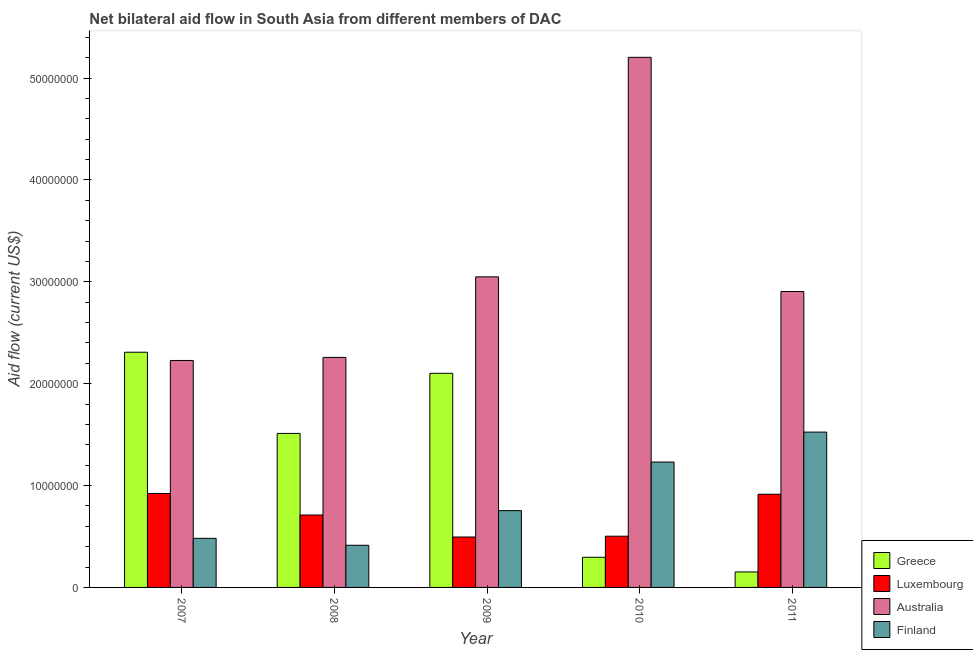How many bars are there on the 4th tick from the left?
Provide a short and direct response. 4. How many bars are there on the 1st tick from the right?
Your answer should be very brief. 4. What is the label of the 5th group of bars from the left?
Your answer should be compact. 2011. In how many cases, is the number of bars for a given year not equal to the number of legend labels?
Your response must be concise. 0. What is the amount of aid given by australia in 2008?
Provide a short and direct response. 2.26e+07. Across all years, what is the maximum amount of aid given by greece?
Offer a terse response. 2.31e+07. Across all years, what is the minimum amount of aid given by finland?
Ensure brevity in your answer.  4.14e+06. In which year was the amount of aid given by greece minimum?
Your answer should be very brief. 2011. What is the total amount of aid given by finland in the graph?
Offer a very short reply. 4.41e+07. What is the difference between the amount of aid given by luxembourg in 2007 and that in 2011?
Ensure brevity in your answer.  7.00e+04. What is the difference between the amount of aid given by australia in 2008 and the amount of aid given by luxembourg in 2011?
Your answer should be compact. -6.47e+06. What is the average amount of aid given by finland per year?
Make the answer very short. 8.81e+06. In the year 2011, what is the difference between the amount of aid given by luxembourg and amount of aid given by finland?
Provide a short and direct response. 0. In how many years, is the amount of aid given by finland greater than 18000000 US$?
Give a very brief answer. 0. What is the ratio of the amount of aid given by finland in 2007 to that in 2009?
Ensure brevity in your answer.  0.64. What is the difference between the highest and the second highest amount of aid given by australia?
Give a very brief answer. 2.16e+07. What is the difference between the highest and the lowest amount of aid given by finland?
Provide a short and direct response. 1.11e+07. In how many years, is the amount of aid given by greece greater than the average amount of aid given by greece taken over all years?
Give a very brief answer. 3. What does the 2nd bar from the left in 2008 represents?
Your answer should be compact. Luxembourg. How many bars are there?
Provide a short and direct response. 20. Are all the bars in the graph horizontal?
Provide a short and direct response. No. What is the difference between two consecutive major ticks on the Y-axis?
Offer a terse response. 1.00e+07. Are the values on the major ticks of Y-axis written in scientific E-notation?
Offer a very short reply. No. Does the graph contain grids?
Provide a succinct answer. No. Where does the legend appear in the graph?
Provide a short and direct response. Bottom right. How are the legend labels stacked?
Ensure brevity in your answer.  Vertical. What is the title of the graph?
Make the answer very short. Net bilateral aid flow in South Asia from different members of DAC. Does "Taxes on exports" appear as one of the legend labels in the graph?
Offer a terse response. No. What is the Aid flow (current US$) in Greece in 2007?
Ensure brevity in your answer.  2.31e+07. What is the Aid flow (current US$) of Luxembourg in 2007?
Give a very brief answer. 9.22e+06. What is the Aid flow (current US$) of Australia in 2007?
Keep it short and to the point. 2.23e+07. What is the Aid flow (current US$) in Finland in 2007?
Make the answer very short. 4.82e+06. What is the Aid flow (current US$) of Greece in 2008?
Your response must be concise. 1.51e+07. What is the Aid flow (current US$) in Luxembourg in 2008?
Provide a succinct answer. 7.11e+06. What is the Aid flow (current US$) in Australia in 2008?
Offer a terse response. 2.26e+07. What is the Aid flow (current US$) in Finland in 2008?
Ensure brevity in your answer.  4.14e+06. What is the Aid flow (current US$) in Greece in 2009?
Provide a succinct answer. 2.10e+07. What is the Aid flow (current US$) of Luxembourg in 2009?
Provide a succinct answer. 4.95e+06. What is the Aid flow (current US$) of Australia in 2009?
Ensure brevity in your answer.  3.05e+07. What is the Aid flow (current US$) in Finland in 2009?
Your answer should be compact. 7.54e+06. What is the Aid flow (current US$) of Greece in 2010?
Your answer should be compact. 2.96e+06. What is the Aid flow (current US$) in Luxembourg in 2010?
Offer a terse response. 5.03e+06. What is the Aid flow (current US$) in Australia in 2010?
Make the answer very short. 5.20e+07. What is the Aid flow (current US$) in Finland in 2010?
Your response must be concise. 1.23e+07. What is the Aid flow (current US$) of Greece in 2011?
Keep it short and to the point. 1.52e+06. What is the Aid flow (current US$) of Luxembourg in 2011?
Make the answer very short. 9.15e+06. What is the Aid flow (current US$) of Australia in 2011?
Ensure brevity in your answer.  2.90e+07. What is the Aid flow (current US$) of Finland in 2011?
Provide a short and direct response. 1.52e+07. Across all years, what is the maximum Aid flow (current US$) of Greece?
Your response must be concise. 2.31e+07. Across all years, what is the maximum Aid flow (current US$) of Luxembourg?
Offer a terse response. 9.22e+06. Across all years, what is the maximum Aid flow (current US$) in Australia?
Your response must be concise. 5.20e+07. Across all years, what is the maximum Aid flow (current US$) in Finland?
Provide a succinct answer. 1.52e+07. Across all years, what is the minimum Aid flow (current US$) of Greece?
Ensure brevity in your answer.  1.52e+06. Across all years, what is the minimum Aid flow (current US$) of Luxembourg?
Your answer should be very brief. 4.95e+06. Across all years, what is the minimum Aid flow (current US$) of Australia?
Offer a terse response. 2.23e+07. Across all years, what is the minimum Aid flow (current US$) in Finland?
Ensure brevity in your answer.  4.14e+06. What is the total Aid flow (current US$) of Greece in the graph?
Your answer should be compact. 6.37e+07. What is the total Aid flow (current US$) in Luxembourg in the graph?
Offer a very short reply. 3.55e+07. What is the total Aid flow (current US$) in Australia in the graph?
Give a very brief answer. 1.56e+08. What is the total Aid flow (current US$) in Finland in the graph?
Give a very brief answer. 4.41e+07. What is the difference between the Aid flow (current US$) of Greece in 2007 and that in 2008?
Give a very brief answer. 7.97e+06. What is the difference between the Aid flow (current US$) of Luxembourg in 2007 and that in 2008?
Offer a terse response. 2.11e+06. What is the difference between the Aid flow (current US$) in Finland in 2007 and that in 2008?
Provide a succinct answer. 6.80e+05. What is the difference between the Aid flow (current US$) in Greece in 2007 and that in 2009?
Keep it short and to the point. 2.07e+06. What is the difference between the Aid flow (current US$) of Luxembourg in 2007 and that in 2009?
Ensure brevity in your answer.  4.27e+06. What is the difference between the Aid flow (current US$) of Australia in 2007 and that in 2009?
Your answer should be compact. -8.21e+06. What is the difference between the Aid flow (current US$) of Finland in 2007 and that in 2009?
Offer a terse response. -2.72e+06. What is the difference between the Aid flow (current US$) in Greece in 2007 and that in 2010?
Your answer should be compact. 2.01e+07. What is the difference between the Aid flow (current US$) in Luxembourg in 2007 and that in 2010?
Your answer should be compact. 4.19e+06. What is the difference between the Aid flow (current US$) in Australia in 2007 and that in 2010?
Offer a terse response. -2.98e+07. What is the difference between the Aid flow (current US$) of Finland in 2007 and that in 2010?
Your answer should be compact. -7.49e+06. What is the difference between the Aid flow (current US$) of Greece in 2007 and that in 2011?
Offer a very short reply. 2.16e+07. What is the difference between the Aid flow (current US$) of Luxembourg in 2007 and that in 2011?
Offer a terse response. 7.00e+04. What is the difference between the Aid flow (current US$) of Australia in 2007 and that in 2011?
Ensure brevity in your answer.  -6.77e+06. What is the difference between the Aid flow (current US$) of Finland in 2007 and that in 2011?
Give a very brief answer. -1.04e+07. What is the difference between the Aid flow (current US$) of Greece in 2008 and that in 2009?
Keep it short and to the point. -5.90e+06. What is the difference between the Aid flow (current US$) of Luxembourg in 2008 and that in 2009?
Your answer should be compact. 2.16e+06. What is the difference between the Aid flow (current US$) of Australia in 2008 and that in 2009?
Ensure brevity in your answer.  -7.91e+06. What is the difference between the Aid flow (current US$) of Finland in 2008 and that in 2009?
Ensure brevity in your answer.  -3.40e+06. What is the difference between the Aid flow (current US$) in Greece in 2008 and that in 2010?
Your answer should be compact. 1.22e+07. What is the difference between the Aid flow (current US$) in Luxembourg in 2008 and that in 2010?
Make the answer very short. 2.08e+06. What is the difference between the Aid flow (current US$) of Australia in 2008 and that in 2010?
Your response must be concise. -2.95e+07. What is the difference between the Aid flow (current US$) of Finland in 2008 and that in 2010?
Make the answer very short. -8.17e+06. What is the difference between the Aid flow (current US$) in Greece in 2008 and that in 2011?
Provide a short and direct response. 1.36e+07. What is the difference between the Aid flow (current US$) of Luxembourg in 2008 and that in 2011?
Your answer should be very brief. -2.04e+06. What is the difference between the Aid flow (current US$) in Australia in 2008 and that in 2011?
Provide a succinct answer. -6.47e+06. What is the difference between the Aid flow (current US$) of Finland in 2008 and that in 2011?
Provide a short and direct response. -1.11e+07. What is the difference between the Aid flow (current US$) of Greece in 2009 and that in 2010?
Your response must be concise. 1.81e+07. What is the difference between the Aid flow (current US$) in Luxembourg in 2009 and that in 2010?
Your response must be concise. -8.00e+04. What is the difference between the Aid flow (current US$) in Australia in 2009 and that in 2010?
Give a very brief answer. -2.16e+07. What is the difference between the Aid flow (current US$) of Finland in 2009 and that in 2010?
Offer a very short reply. -4.77e+06. What is the difference between the Aid flow (current US$) in Greece in 2009 and that in 2011?
Keep it short and to the point. 1.95e+07. What is the difference between the Aid flow (current US$) of Luxembourg in 2009 and that in 2011?
Make the answer very short. -4.20e+06. What is the difference between the Aid flow (current US$) in Australia in 2009 and that in 2011?
Offer a terse response. 1.44e+06. What is the difference between the Aid flow (current US$) in Finland in 2009 and that in 2011?
Keep it short and to the point. -7.71e+06. What is the difference between the Aid flow (current US$) of Greece in 2010 and that in 2011?
Your response must be concise. 1.44e+06. What is the difference between the Aid flow (current US$) in Luxembourg in 2010 and that in 2011?
Ensure brevity in your answer.  -4.12e+06. What is the difference between the Aid flow (current US$) of Australia in 2010 and that in 2011?
Give a very brief answer. 2.30e+07. What is the difference between the Aid flow (current US$) in Finland in 2010 and that in 2011?
Make the answer very short. -2.94e+06. What is the difference between the Aid flow (current US$) in Greece in 2007 and the Aid flow (current US$) in Luxembourg in 2008?
Ensure brevity in your answer.  1.60e+07. What is the difference between the Aid flow (current US$) in Greece in 2007 and the Aid flow (current US$) in Australia in 2008?
Offer a very short reply. 5.10e+05. What is the difference between the Aid flow (current US$) in Greece in 2007 and the Aid flow (current US$) in Finland in 2008?
Your answer should be very brief. 1.90e+07. What is the difference between the Aid flow (current US$) of Luxembourg in 2007 and the Aid flow (current US$) of Australia in 2008?
Provide a succinct answer. -1.34e+07. What is the difference between the Aid flow (current US$) in Luxembourg in 2007 and the Aid flow (current US$) in Finland in 2008?
Give a very brief answer. 5.08e+06. What is the difference between the Aid flow (current US$) in Australia in 2007 and the Aid flow (current US$) in Finland in 2008?
Your answer should be very brief. 1.81e+07. What is the difference between the Aid flow (current US$) in Greece in 2007 and the Aid flow (current US$) in Luxembourg in 2009?
Your response must be concise. 1.81e+07. What is the difference between the Aid flow (current US$) of Greece in 2007 and the Aid flow (current US$) of Australia in 2009?
Provide a short and direct response. -7.40e+06. What is the difference between the Aid flow (current US$) of Greece in 2007 and the Aid flow (current US$) of Finland in 2009?
Your response must be concise. 1.56e+07. What is the difference between the Aid flow (current US$) of Luxembourg in 2007 and the Aid flow (current US$) of Australia in 2009?
Make the answer very short. -2.13e+07. What is the difference between the Aid flow (current US$) of Luxembourg in 2007 and the Aid flow (current US$) of Finland in 2009?
Provide a succinct answer. 1.68e+06. What is the difference between the Aid flow (current US$) in Australia in 2007 and the Aid flow (current US$) in Finland in 2009?
Ensure brevity in your answer.  1.47e+07. What is the difference between the Aid flow (current US$) of Greece in 2007 and the Aid flow (current US$) of Luxembourg in 2010?
Make the answer very short. 1.81e+07. What is the difference between the Aid flow (current US$) in Greece in 2007 and the Aid flow (current US$) in Australia in 2010?
Provide a succinct answer. -2.90e+07. What is the difference between the Aid flow (current US$) of Greece in 2007 and the Aid flow (current US$) of Finland in 2010?
Offer a terse response. 1.08e+07. What is the difference between the Aid flow (current US$) in Luxembourg in 2007 and the Aid flow (current US$) in Australia in 2010?
Give a very brief answer. -4.28e+07. What is the difference between the Aid flow (current US$) in Luxembourg in 2007 and the Aid flow (current US$) in Finland in 2010?
Provide a succinct answer. -3.09e+06. What is the difference between the Aid flow (current US$) in Australia in 2007 and the Aid flow (current US$) in Finland in 2010?
Ensure brevity in your answer.  9.97e+06. What is the difference between the Aid flow (current US$) of Greece in 2007 and the Aid flow (current US$) of Luxembourg in 2011?
Keep it short and to the point. 1.39e+07. What is the difference between the Aid flow (current US$) of Greece in 2007 and the Aid flow (current US$) of Australia in 2011?
Make the answer very short. -5.96e+06. What is the difference between the Aid flow (current US$) of Greece in 2007 and the Aid flow (current US$) of Finland in 2011?
Provide a succinct answer. 7.84e+06. What is the difference between the Aid flow (current US$) in Luxembourg in 2007 and the Aid flow (current US$) in Australia in 2011?
Your answer should be compact. -1.98e+07. What is the difference between the Aid flow (current US$) of Luxembourg in 2007 and the Aid flow (current US$) of Finland in 2011?
Your answer should be very brief. -6.03e+06. What is the difference between the Aid flow (current US$) in Australia in 2007 and the Aid flow (current US$) in Finland in 2011?
Your answer should be very brief. 7.03e+06. What is the difference between the Aid flow (current US$) of Greece in 2008 and the Aid flow (current US$) of Luxembourg in 2009?
Your response must be concise. 1.02e+07. What is the difference between the Aid flow (current US$) in Greece in 2008 and the Aid flow (current US$) in Australia in 2009?
Give a very brief answer. -1.54e+07. What is the difference between the Aid flow (current US$) in Greece in 2008 and the Aid flow (current US$) in Finland in 2009?
Ensure brevity in your answer.  7.58e+06. What is the difference between the Aid flow (current US$) in Luxembourg in 2008 and the Aid flow (current US$) in Australia in 2009?
Provide a succinct answer. -2.34e+07. What is the difference between the Aid flow (current US$) in Luxembourg in 2008 and the Aid flow (current US$) in Finland in 2009?
Offer a terse response. -4.30e+05. What is the difference between the Aid flow (current US$) of Australia in 2008 and the Aid flow (current US$) of Finland in 2009?
Your response must be concise. 1.50e+07. What is the difference between the Aid flow (current US$) in Greece in 2008 and the Aid flow (current US$) in Luxembourg in 2010?
Make the answer very short. 1.01e+07. What is the difference between the Aid flow (current US$) in Greece in 2008 and the Aid flow (current US$) in Australia in 2010?
Give a very brief answer. -3.69e+07. What is the difference between the Aid flow (current US$) in Greece in 2008 and the Aid flow (current US$) in Finland in 2010?
Offer a terse response. 2.81e+06. What is the difference between the Aid flow (current US$) in Luxembourg in 2008 and the Aid flow (current US$) in Australia in 2010?
Make the answer very short. -4.49e+07. What is the difference between the Aid flow (current US$) in Luxembourg in 2008 and the Aid flow (current US$) in Finland in 2010?
Offer a terse response. -5.20e+06. What is the difference between the Aid flow (current US$) in Australia in 2008 and the Aid flow (current US$) in Finland in 2010?
Keep it short and to the point. 1.03e+07. What is the difference between the Aid flow (current US$) of Greece in 2008 and the Aid flow (current US$) of Luxembourg in 2011?
Keep it short and to the point. 5.97e+06. What is the difference between the Aid flow (current US$) in Greece in 2008 and the Aid flow (current US$) in Australia in 2011?
Keep it short and to the point. -1.39e+07. What is the difference between the Aid flow (current US$) of Greece in 2008 and the Aid flow (current US$) of Finland in 2011?
Ensure brevity in your answer.  -1.30e+05. What is the difference between the Aid flow (current US$) of Luxembourg in 2008 and the Aid flow (current US$) of Australia in 2011?
Provide a succinct answer. -2.19e+07. What is the difference between the Aid flow (current US$) of Luxembourg in 2008 and the Aid flow (current US$) of Finland in 2011?
Give a very brief answer. -8.14e+06. What is the difference between the Aid flow (current US$) in Australia in 2008 and the Aid flow (current US$) in Finland in 2011?
Ensure brevity in your answer.  7.33e+06. What is the difference between the Aid flow (current US$) in Greece in 2009 and the Aid flow (current US$) in Luxembourg in 2010?
Provide a short and direct response. 1.60e+07. What is the difference between the Aid flow (current US$) in Greece in 2009 and the Aid flow (current US$) in Australia in 2010?
Offer a very short reply. -3.10e+07. What is the difference between the Aid flow (current US$) of Greece in 2009 and the Aid flow (current US$) of Finland in 2010?
Your answer should be compact. 8.71e+06. What is the difference between the Aid flow (current US$) of Luxembourg in 2009 and the Aid flow (current US$) of Australia in 2010?
Offer a terse response. -4.71e+07. What is the difference between the Aid flow (current US$) of Luxembourg in 2009 and the Aid flow (current US$) of Finland in 2010?
Keep it short and to the point. -7.36e+06. What is the difference between the Aid flow (current US$) in Australia in 2009 and the Aid flow (current US$) in Finland in 2010?
Keep it short and to the point. 1.82e+07. What is the difference between the Aid flow (current US$) in Greece in 2009 and the Aid flow (current US$) in Luxembourg in 2011?
Keep it short and to the point. 1.19e+07. What is the difference between the Aid flow (current US$) in Greece in 2009 and the Aid flow (current US$) in Australia in 2011?
Give a very brief answer. -8.03e+06. What is the difference between the Aid flow (current US$) in Greece in 2009 and the Aid flow (current US$) in Finland in 2011?
Your answer should be compact. 5.77e+06. What is the difference between the Aid flow (current US$) of Luxembourg in 2009 and the Aid flow (current US$) of Australia in 2011?
Give a very brief answer. -2.41e+07. What is the difference between the Aid flow (current US$) in Luxembourg in 2009 and the Aid flow (current US$) in Finland in 2011?
Give a very brief answer. -1.03e+07. What is the difference between the Aid flow (current US$) in Australia in 2009 and the Aid flow (current US$) in Finland in 2011?
Provide a succinct answer. 1.52e+07. What is the difference between the Aid flow (current US$) of Greece in 2010 and the Aid flow (current US$) of Luxembourg in 2011?
Offer a terse response. -6.19e+06. What is the difference between the Aid flow (current US$) in Greece in 2010 and the Aid flow (current US$) in Australia in 2011?
Your answer should be very brief. -2.61e+07. What is the difference between the Aid flow (current US$) in Greece in 2010 and the Aid flow (current US$) in Finland in 2011?
Provide a short and direct response. -1.23e+07. What is the difference between the Aid flow (current US$) of Luxembourg in 2010 and the Aid flow (current US$) of Australia in 2011?
Provide a short and direct response. -2.40e+07. What is the difference between the Aid flow (current US$) in Luxembourg in 2010 and the Aid flow (current US$) in Finland in 2011?
Your answer should be very brief. -1.02e+07. What is the difference between the Aid flow (current US$) of Australia in 2010 and the Aid flow (current US$) of Finland in 2011?
Your answer should be compact. 3.68e+07. What is the average Aid flow (current US$) in Greece per year?
Offer a terse response. 1.27e+07. What is the average Aid flow (current US$) in Luxembourg per year?
Give a very brief answer. 7.09e+06. What is the average Aid flow (current US$) in Australia per year?
Give a very brief answer. 3.13e+07. What is the average Aid flow (current US$) in Finland per year?
Provide a succinct answer. 8.81e+06. In the year 2007, what is the difference between the Aid flow (current US$) in Greece and Aid flow (current US$) in Luxembourg?
Give a very brief answer. 1.39e+07. In the year 2007, what is the difference between the Aid flow (current US$) in Greece and Aid flow (current US$) in Australia?
Your answer should be compact. 8.10e+05. In the year 2007, what is the difference between the Aid flow (current US$) in Greece and Aid flow (current US$) in Finland?
Offer a terse response. 1.83e+07. In the year 2007, what is the difference between the Aid flow (current US$) of Luxembourg and Aid flow (current US$) of Australia?
Give a very brief answer. -1.31e+07. In the year 2007, what is the difference between the Aid flow (current US$) of Luxembourg and Aid flow (current US$) of Finland?
Keep it short and to the point. 4.40e+06. In the year 2007, what is the difference between the Aid flow (current US$) of Australia and Aid flow (current US$) of Finland?
Your response must be concise. 1.75e+07. In the year 2008, what is the difference between the Aid flow (current US$) in Greece and Aid flow (current US$) in Luxembourg?
Provide a succinct answer. 8.01e+06. In the year 2008, what is the difference between the Aid flow (current US$) of Greece and Aid flow (current US$) of Australia?
Your answer should be very brief. -7.46e+06. In the year 2008, what is the difference between the Aid flow (current US$) of Greece and Aid flow (current US$) of Finland?
Ensure brevity in your answer.  1.10e+07. In the year 2008, what is the difference between the Aid flow (current US$) in Luxembourg and Aid flow (current US$) in Australia?
Provide a succinct answer. -1.55e+07. In the year 2008, what is the difference between the Aid flow (current US$) in Luxembourg and Aid flow (current US$) in Finland?
Give a very brief answer. 2.97e+06. In the year 2008, what is the difference between the Aid flow (current US$) in Australia and Aid flow (current US$) in Finland?
Offer a very short reply. 1.84e+07. In the year 2009, what is the difference between the Aid flow (current US$) in Greece and Aid flow (current US$) in Luxembourg?
Keep it short and to the point. 1.61e+07. In the year 2009, what is the difference between the Aid flow (current US$) of Greece and Aid flow (current US$) of Australia?
Offer a terse response. -9.47e+06. In the year 2009, what is the difference between the Aid flow (current US$) in Greece and Aid flow (current US$) in Finland?
Make the answer very short. 1.35e+07. In the year 2009, what is the difference between the Aid flow (current US$) of Luxembourg and Aid flow (current US$) of Australia?
Make the answer very short. -2.55e+07. In the year 2009, what is the difference between the Aid flow (current US$) of Luxembourg and Aid flow (current US$) of Finland?
Offer a very short reply. -2.59e+06. In the year 2009, what is the difference between the Aid flow (current US$) of Australia and Aid flow (current US$) of Finland?
Give a very brief answer. 2.30e+07. In the year 2010, what is the difference between the Aid flow (current US$) of Greece and Aid flow (current US$) of Luxembourg?
Offer a very short reply. -2.07e+06. In the year 2010, what is the difference between the Aid flow (current US$) of Greece and Aid flow (current US$) of Australia?
Offer a terse response. -4.91e+07. In the year 2010, what is the difference between the Aid flow (current US$) in Greece and Aid flow (current US$) in Finland?
Your answer should be compact. -9.35e+06. In the year 2010, what is the difference between the Aid flow (current US$) in Luxembourg and Aid flow (current US$) in Australia?
Make the answer very short. -4.70e+07. In the year 2010, what is the difference between the Aid flow (current US$) of Luxembourg and Aid flow (current US$) of Finland?
Your response must be concise. -7.28e+06. In the year 2010, what is the difference between the Aid flow (current US$) in Australia and Aid flow (current US$) in Finland?
Give a very brief answer. 3.97e+07. In the year 2011, what is the difference between the Aid flow (current US$) in Greece and Aid flow (current US$) in Luxembourg?
Provide a succinct answer. -7.63e+06. In the year 2011, what is the difference between the Aid flow (current US$) in Greece and Aid flow (current US$) in Australia?
Your answer should be compact. -2.75e+07. In the year 2011, what is the difference between the Aid flow (current US$) in Greece and Aid flow (current US$) in Finland?
Offer a terse response. -1.37e+07. In the year 2011, what is the difference between the Aid flow (current US$) of Luxembourg and Aid flow (current US$) of Australia?
Provide a succinct answer. -1.99e+07. In the year 2011, what is the difference between the Aid flow (current US$) of Luxembourg and Aid flow (current US$) of Finland?
Ensure brevity in your answer.  -6.10e+06. In the year 2011, what is the difference between the Aid flow (current US$) in Australia and Aid flow (current US$) in Finland?
Give a very brief answer. 1.38e+07. What is the ratio of the Aid flow (current US$) of Greece in 2007 to that in 2008?
Offer a terse response. 1.53. What is the ratio of the Aid flow (current US$) of Luxembourg in 2007 to that in 2008?
Your response must be concise. 1.3. What is the ratio of the Aid flow (current US$) of Australia in 2007 to that in 2008?
Ensure brevity in your answer.  0.99. What is the ratio of the Aid flow (current US$) of Finland in 2007 to that in 2008?
Offer a terse response. 1.16. What is the ratio of the Aid flow (current US$) in Greece in 2007 to that in 2009?
Give a very brief answer. 1.1. What is the ratio of the Aid flow (current US$) of Luxembourg in 2007 to that in 2009?
Your answer should be compact. 1.86. What is the ratio of the Aid flow (current US$) in Australia in 2007 to that in 2009?
Give a very brief answer. 0.73. What is the ratio of the Aid flow (current US$) of Finland in 2007 to that in 2009?
Ensure brevity in your answer.  0.64. What is the ratio of the Aid flow (current US$) in Greece in 2007 to that in 2010?
Offer a very short reply. 7.8. What is the ratio of the Aid flow (current US$) of Luxembourg in 2007 to that in 2010?
Give a very brief answer. 1.83. What is the ratio of the Aid flow (current US$) in Australia in 2007 to that in 2010?
Give a very brief answer. 0.43. What is the ratio of the Aid flow (current US$) in Finland in 2007 to that in 2010?
Provide a succinct answer. 0.39. What is the ratio of the Aid flow (current US$) of Greece in 2007 to that in 2011?
Give a very brief answer. 15.19. What is the ratio of the Aid flow (current US$) in Luxembourg in 2007 to that in 2011?
Your response must be concise. 1.01. What is the ratio of the Aid flow (current US$) in Australia in 2007 to that in 2011?
Provide a succinct answer. 0.77. What is the ratio of the Aid flow (current US$) in Finland in 2007 to that in 2011?
Your answer should be compact. 0.32. What is the ratio of the Aid flow (current US$) of Greece in 2008 to that in 2009?
Make the answer very short. 0.72. What is the ratio of the Aid flow (current US$) in Luxembourg in 2008 to that in 2009?
Keep it short and to the point. 1.44. What is the ratio of the Aid flow (current US$) of Australia in 2008 to that in 2009?
Your answer should be compact. 0.74. What is the ratio of the Aid flow (current US$) in Finland in 2008 to that in 2009?
Offer a terse response. 0.55. What is the ratio of the Aid flow (current US$) of Greece in 2008 to that in 2010?
Keep it short and to the point. 5.11. What is the ratio of the Aid flow (current US$) of Luxembourg in 2008 to that in 2010?
Your answer should be very brief. 1.41. What is the ratio of the Aid flow (current US$) in Australia in 2008 to that in 2010?
Your answer should be compact. 0.43. What is the ratio of the Aid flow (current US$) of Finland in 2008 to that in 2010?
Your answer should be compact. 0.34. What is the ratio of the Aid flow (current US$) in Greece in 2008 to that in 2011?
Provide a succinct answer. 9.95. What is the ratio of the Aid flow (current US$) in Luxembourg in 2008 to that in 2011?
Provide a succinct answer. 0.78. What is the ratio of the Aid flow (current US$) in Australia in 2008 to that in 2011?
Your answer should be very brief. 0.78. What is the ratio of the Aid flow (current US$) of Finland in 2008 to that in 2011?
Give a very brief answer. 0.27. What is the ratio of the Aid flow (current US$) of Greece in 2009 to that in 2010?
Your response must be concise. 7.1. What is the ratio of the Aid flow (current US$) in Luxembourg in 2009 to that in 2010?
Your answer should be very brief. 0.98. What is the ratio of the Aid flow (current US$) of Australia in 2009 to that in 2010?
Offer a very short reply. 0.59. What is the ratio of the Aid flow (current US$) in Finland in 2009 to that in 2010?
Offer a very short reply. 0.61. What is the ratio of the Aid flow (current US$) in Greece in 2009 to that in 2011?
Your answer should be compact. 13.83. What is the ratio of the Aid flow (current US$) of Luxembourg in 2009 to that in 2011?
Offer a terse response. 0.54. What is the ratio of the Aid flow (current US$) of Australia in 2009 to that in 2011?
Offer a terse response. 1.05. What is the ratio of the Aid flow (current US$) in Finland in 2009 to that in 2011?
Offer a terse response. 0.49. What is the ratio of the Aid flow (current US$) of Greece in 2010 to that in 2011?
Provide a short and direct response. 1.95. What is the ratio of the Aid flow (current US$) of Luxembourg in 2010 to that in 2011?
Give a very brief answer. 0.55. What is the ratio of the Aid flow (current US$) of Australia in 2010 to that in 2011?
Give a very brief answer. 1.79. What is the ratio of the Aid flow (current US$) in Finland in 2010 to that in 2011?
Make the answer very short. 0.81. What is the difference between the highest and the second highest Aid flow (current US$) of Greece?
Offer a very short reply. 2.07e+06. What is the difference between the highest and the second highest Aid flow (current US$) in Australia?
Provide a succinct answer. 2.16e+07. What is the difference between the highest and the second highest Aid flow (current US$) in Finland?
Ensure brevity in your answer.  2.94e+06. What is the difference between the highest and the lowest Aid flow (current US$) in Greece?
Provide a short and direct response. 2.16e+07. What is the difference between the highest and the lowest Aid flow (current US$) in Luxembourg?
Provide a succinct answer. 4.27e+06. What is the difference between the highest and the lowest Aid flow (current US$) in Australia?
Your response must be concise. 2.98e+07. What is the difference between the highest and the lowest Aid flow (current US$) in Finland?
Give a very brief answer. 1.11e+07. 